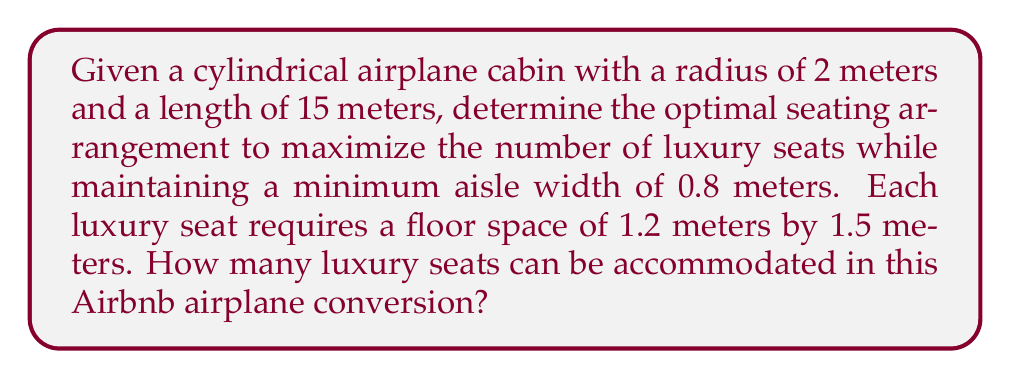Give your solution to this math problem. To solve this problem, we need to consider the cylindrical geometry of the airplane cabin and the constraints of the luxury seats and aisle. Let's approach this step-by-step:

1. Calculate the circumference of the cabin:
   $$C = 2\pi r = 2\pi(2) = 4\pi \approx 12.57 \text{ meters}$$

2. Subtract the aisle width from the circumference:
   $$\text{Available width} = 12.57 - 0.8 = 11.77 \text{ meters}$$

3. Determine the number of seats that can fit around the circumference:
   $$\text{Seats per row} = \left\lfloor\frac{11.77}{1.2}\right\rfloor = 9 \text{ seats}$$

4. Calculate the number of rows that can fit along the length:
   $$\text{Number of rows} = \left\lfloor\frac{15}{1.5}\right\rfloor = 10 \text{ rows}$$

5. Calculate the total number of seats:
   $$\text{Total seats} = 9 \times 10 = 90 \text{ seats}$$

To visualize this arrangement, we can use the following Asymptote diagram:

[asy]
import geometry;

unitsize(20);
real r = 2;
real L = 15;
real seatWidth = 1.2;
real seatLength = 1.5;
real aisleWidth = 0.8;

// Draw cabin outline
draw(circle((0,0),r));
draw((0,-r)--(0,r));
draw((L,-r)--(L,r));

// Draw aisle
draw((0,aisleWidth/2)--(L,aisleWidth/2), dashed);
draw((0,-aisleWidth/2)--(L,-aisleWidth/2), dashed);

// Draw seats (simplified representation)
for(int i = 0; i < 10; ++i) {
    for(int j = 0; j < 9; ++j) {
        real angle = 2*pi*j/9;
        pair center = (i*seatLength + seatLength/2, r*sin(angle));
        draw(circle(center, 0.1), rgb(0,0,1));
    }
}

label("Front", (0,2.5));
label("Rear", (L,2.5));
[/asy]

This arrangement maximizes the number of luxury seats while maintaining the required aisle width and seat dimensions.
Answer: The optimal seating arrangement can accommodate 90 luxury seats in the cylindrical airplane cabin. 